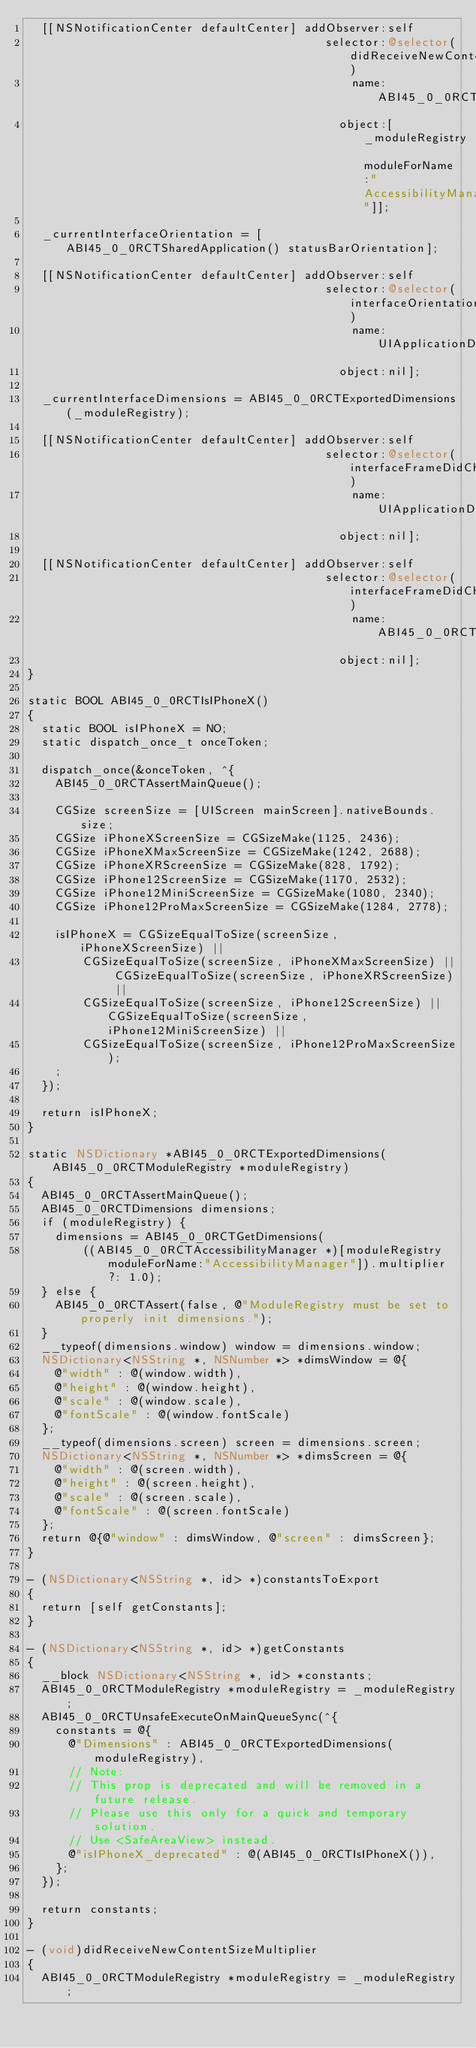Convert code to text. <code><loc_0><loc_0><loc_500><loc_500><_ObjectiveC_>  [[NSNotificationCenter defaultCenter] addObserver:self
                                           selector:@selector(didReceiveNewContentSizeMultiplier)
                                               name:ABI45_0_0RCTAccessibilityManagerDidUpdateMultiplierNotification
                                             object:[_moduleRegistry moduleForName:"AccessibilityManager"]];

  _currentInterfaceOrientation = [ABI45_0_0RCTSharedApplication() statusBarOrientation];

  [[NSNotificationCenter defaultCenter] addObserver:self
                                           selector:@selector(interfaceOrientationDidChange)
                                               name:UIApplicationDidChangeStatusBarOrientationNotification
                                             object:nil];

  _currentInterfaceDimensions = ABI45_0_0RCTExportedDimensions(_moduleRegistry);

  [[NSNotificationCenter defaultCenter] addObserver:self
                                           selector:@selector(interfaceFrameDidChange)
                                               name:UIApplicationDidBecomeActiveNotification
                                             object:nil];

  [[NSNotificationCenter defaultCenter] addObserver:self
                                           selector:@selector(interfaceFrameDidChange)
                                               name:ABI45_0_0RCTUserInterfaceStyleDidChangeNotification
                                             object:nil];
}

static BOOL ABI45_0_0RCTIsIPhoneX()
{
  static BOOL isIPhoneX = NO;
  static dispatch_once_t onceToken;

  dispatch_once(&onceToken, ^{
    ABI45_0_0RCTAssertMainQueue();

    CGSize screenSize = [UIScreen mainScreen].nativeBounds.size;
    CGSize iPhoneXScreenSize = CGSizeMake(1125, 2436);
    CGSize iPhoneXMaxScreenSize = CGSizeMake(1242, 2688);
    CGSize iPhoneXRScreenSize = CGSizeMake(828, 1792);
    CGSize iPhone12ScreenSize = CGSizeMake(1170, 2532);
    CGSize iPhone12MiniScreenSize = CGSizeMake(1080, 2340);
    CGSize iPhone12ProMaxScreenSize = CGSizeMake(1284, 2778);

    isIPhoneX = CGSizeEqualToSize(screenSize, iPhoneXScreenSize) ||
        CGSizeEqualToSize(screenSize, iPhoneXMaxScreenSize) || CGSizeEqualToSize(screenSize, iPhoneXRScreenSize) ||
        CGSizeEqualToSize(screenSize, iPhone12ScreenSize) || CGSizeEqualToSize(screenSize, iPhone12MiniScreenSize) ||
        CGSizeEqualToSize(screenSize, iPhone12ProMaxScreenSize);
    ;
  });

  return isIPhoneX;
}

static NSDictionary *ABI45_0_0RCTExportedDimensions(ABI45_0_0RCTModuleRegistry *moduleRegistry)
{
  ABI45_0_0RCTAssertMainQueue();
  ABI45_0_0RCTDimensions dimensions;
  if (moduleRegistry) {
    dimensions = ABI45_0_0RCTGetDimensions(
        ((ABI45_0_0RCTAccessibilityManager *)[moduleRegistry moduleForName:"AccessibilityManager"]).multiplier ?: 1.0);
  } else {
    ABI45_0_0RCTAssert(false, @"ModuleRegistry must be set to properly init dimensions.");
  }
  __typeof(dimensions.window) window = dimensions.window;
  NSDictionary<NSString *, NSNumber *> *dimsWindow = @{
    @"width" : @(window.width),
    @"height" : @(window.height),
    @"scale" : @(window.scale),
    @"fontScale" : @(window.fontScale)
  };
  __typeof(dimensions.screen) screen = dimensions.screen;
  NSDictionary<NSString *, NSNumber *> *dimsScreen = @{
    @"width" : @(screen.width),
    @"height" : @(screen.height),
    @"scale" : @(screen.scale),
    @"fontScale" : @(screen.fontScale)
  };
  return @{@"window" : dimsWindow, @"screen" : dimsScreen};
}

- (NSDictionary<NSString *, id> *)constantsToExport
{
  return [self getConstants];
}

- (NSDictionary<NSString *, id> *)getConstants
{
  __block NSDictionary<NSString *, id> *constants;
  ABI45_0_0RCTModuleRegistry *moduleRegistry = _moduleRegistry;
  ABI45_0_0RCTUnsafeExecuteOnMainQueueSync(^{
    constants = @{
      @"Dimensions" : ABI45_0_0RCTExportedDimensions(moduleRegistry),
      // Note:
      // This prop is deprecated and will be removed in a future release.
      // Please use this only for a quick and temporary solution.
      // Use <SafeAreaView> instead.
      @"isIPhoneX_deprecated" : @(ABI45_0_0RCTIsIPhoneX()),
    };
  });

  return constants;
}

- (void)didReceiveNewContentSizeMultiplier
{
  ABI45_0_0RCTModuleRegistry *moduleRegistry = _moduleRegistry;</code> 